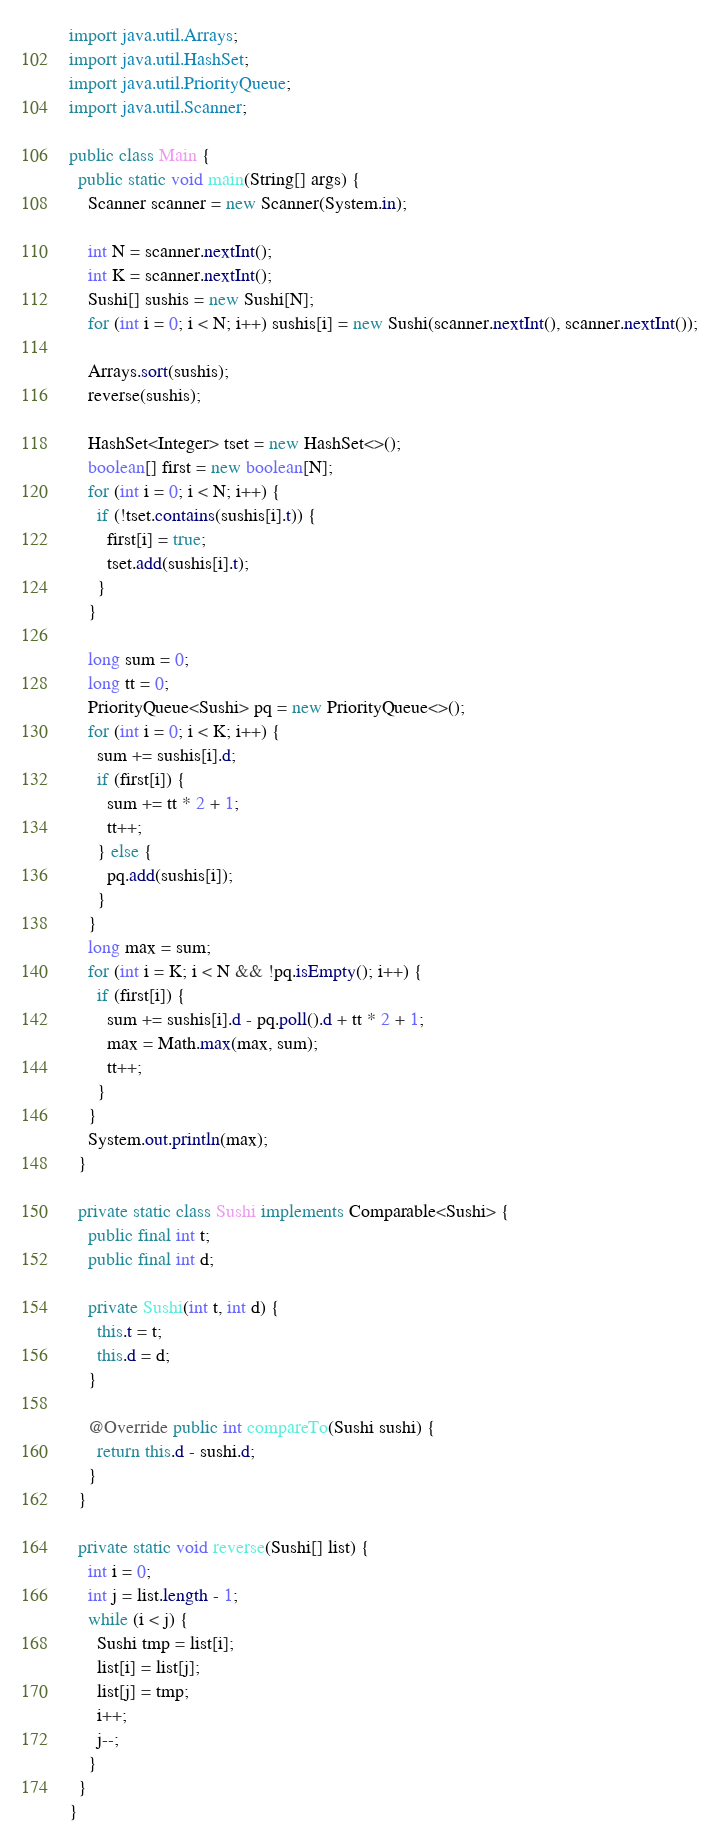<code> <loc_0><loc_0><loc_500><loc_500><_Java_>import java.util.Arrays;
import java.util.HashSet;
import java.util.PriorityQueue;
import java.util.Scanner;

public class Main {
  public static void main(String[] args) {
    Scanner scanner = new Scanner(System.in);

    int N = scanner.nextInt();
    int K = scanner.nextInt();
    Sushi[] sushis = new Sushi[N];
    for (int i = 0; i < N; i++) sushis[i] = new Sushi(scanner.nextInt(), scanner.nextInt());

    Arrays.sort(sushis);
    reverse(sushis);

    HashSet<Integer> tset = new HashSet<>();
    boolean[] first = new boolean[N];
    for (int i = 0; i < N; i++) {
      if (!tset.contains(sushis[i].t)) {
        first[i] = true;
        tset.add(sushis[i].t);
      }
    }

    long sum = 0;
    long tt = 0;
    PriorityQueue<Sushi> pq = new PriorityQueue<>();
    for (int i = 0; i < K; i++) {
      sum += sushis[i].d;
      if (first[i]) {
        sum += tt * 2 + 1;
        tt++;
      } else {
        pq.add(sushis[i]);
      }
    }
    long max = sum;
    for (int i = K; i < N && !pq.isEmpty(); i++) {
      if (first[i]) {
        sum += sushis[i].d - pq.poll().d + tt * 2 + 1;
        max = Math.max(max, sum);
        tt++;
      }
    }
    System.out.println(max);
  }

  private static class Sushi implements Comparable<Sushi> {
    public final int t;
    public final int d;

    private Sushi(int t, int d) {
      this.t = t;
      this.d = d;
    }

    @Override public int compareTo(Sushi sushi) {
      return this.d - sushi.d;
    }
  }

  private static void reverse(Sushi[] list) {
    int i = 0;
    int j = list.length - 1;
    while (i < j) {
      Sushi tmp = list[i];
      list[i] = list[j];
      list[j] = tmp;
      i++;
      j--;
    }
  }
}
</code> 